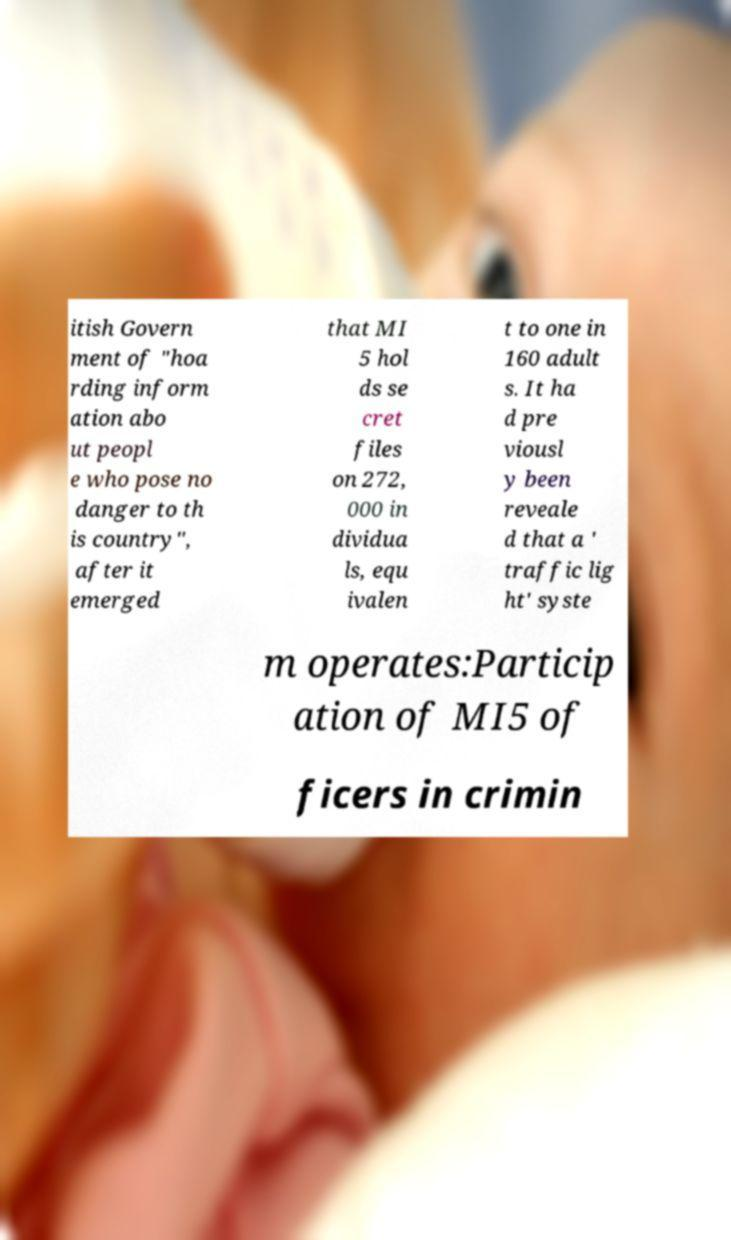Please identify and transcribe the text found in this image. itish Govern ment of "hoa rding inform ation abo ut peopl e who pose no danger to th is country", after it emerged that MI 5 hol ds se cret files on 272, 000 in dividua ls, equ ivalen t to one in 160 adult s. It ha d pre viousl y been reveale d that a ' traffic lig ht' syste m operates:Particip ation of MI5 of ficers in crimin 